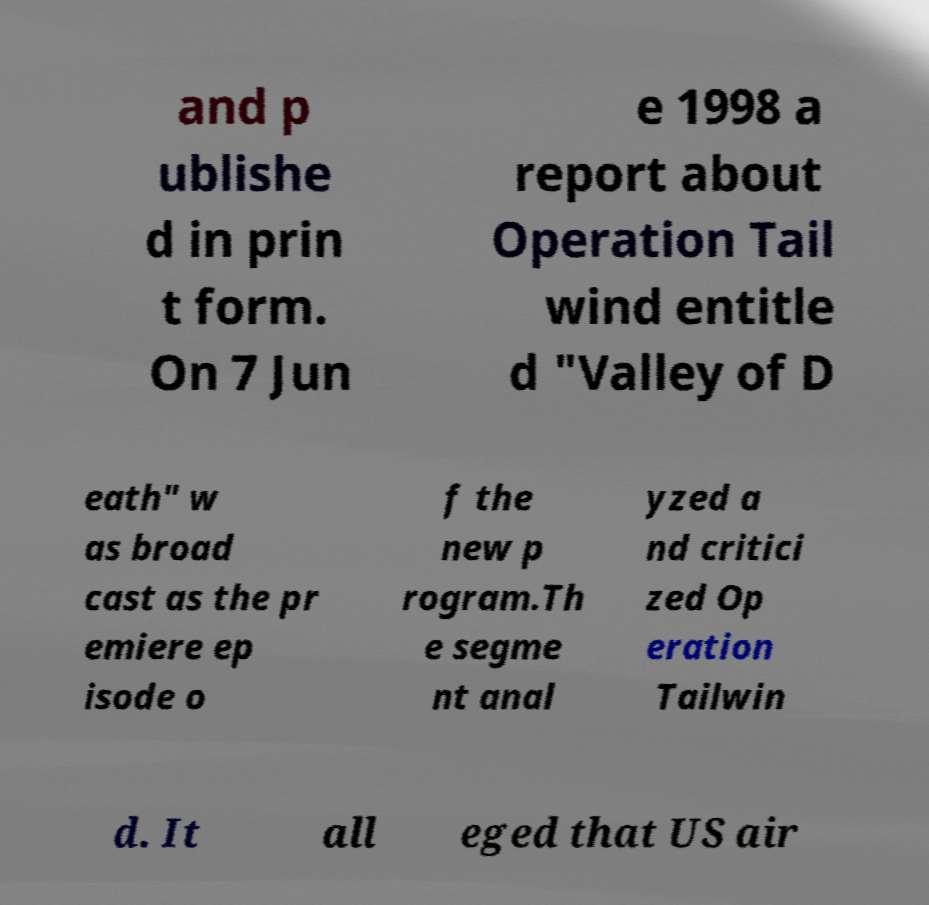Could you extract and type out the text from this image? and p ublishe d in prin t form. On 7 Jun e 1998 a report about Operation Tail wind entitle d "Valley of D eath" w as broad cast as the pr emiere ep isode o f the new p rogram.Th e segme nt anal yzed a nd critici zed Op eration Tailwin d. It all eged that US air 